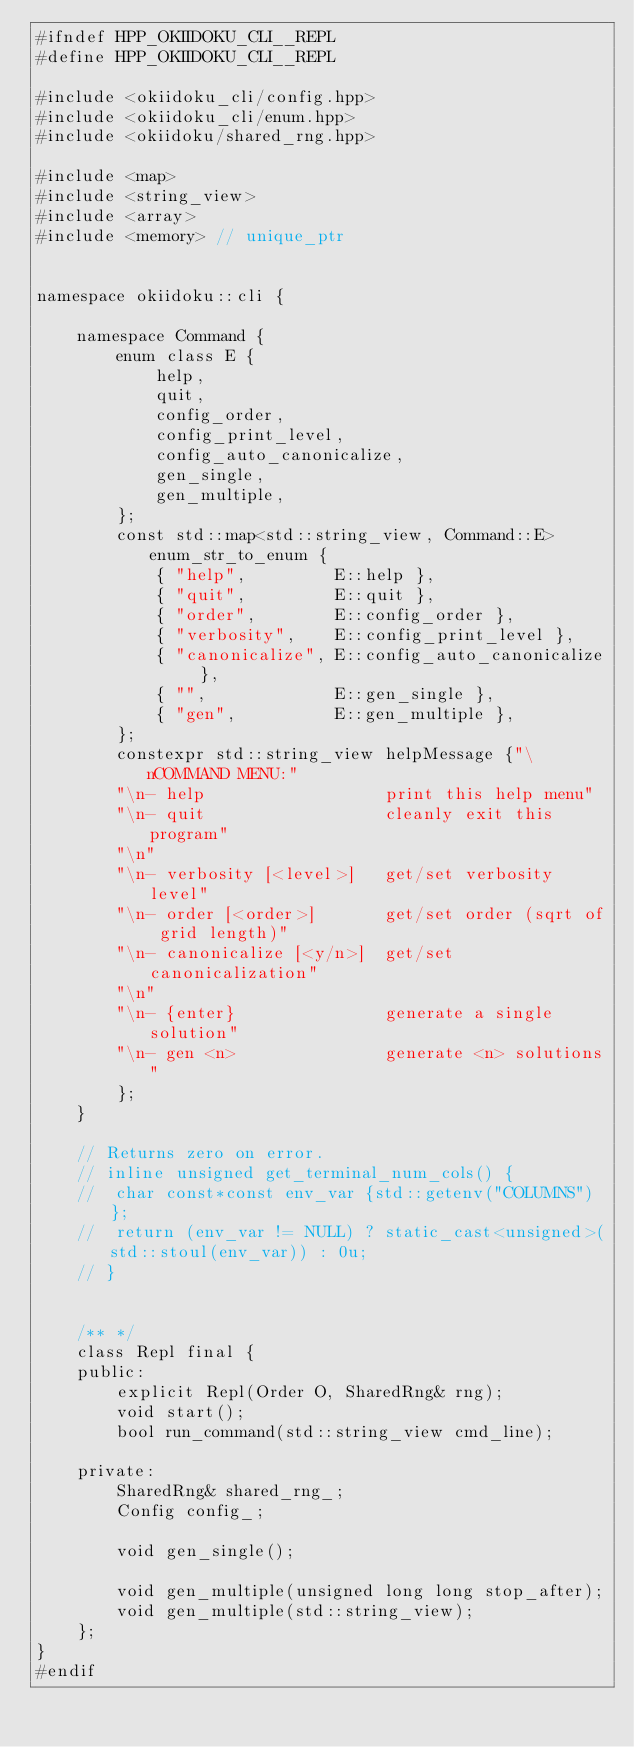Convert code to text. <code><loc_0><loc_0><loc_500><loc_500><_C++_>#ifndef HPP_OKIIDOKU_CLI__REPL
#define HPP_OKIIDOKU_CLI__REPL

#include <okiidoku_cli/config.hpp>
#include <okiidoku_cli/enum.hpp>
#include <okiidoku/shared_rng.hpp>

#include <map>
#include <string_view>
#include <array>
#include <memory> // unique_ptr


namespace okiidoku::cli {

	namespace Command {
		enum class E {
			help,
			quit,
			config_order,
			config_print_level,
			config_auto_canonicalize,
			gen_single,
			gen_multiple,
		};
		const std::map<std::string_view, Command::E> enum_str_to_enum {
			{ "help",         E::help },
			{ "quit",         E::quit },
			{ "order",        E::config_order },
			{ "verbosity",    E::config_print_level },
			{ "canonicalize", E::config_auto_canonicalize },
			{ "",             E::gen_single },
			{ "gen",          E::gen_multiple },
		};
		constexpr std::string_view helpMessage {"\nCOMMAND MENU:"
		"\n- help                  print this help menu"
		"\n- quit                  cleanly exit this program"
		"\n"
		"\n- verbosity [<level>]   get/set verbosity level"
		"\n- order [<order>]       get/set order (sqrt of grid length)"
		"\n- canonicalize [<y/n>]  get/set canonicalization"
		"\n"
		"\n- {enter}               generate a single solution"
		"\n- gen <n>               generate <n> solutions"
		};
	}

	// Returns zero on error.
	// inline unsigned get_terminal_num_cols() {
	// 	char const*const env_var {std::getenv("COLUMNS")};
	// 	return (env_var != NULL) ? static_cast<unsigned>(std::stoul(env_var)) : 0u;
	// }


	/** */
	class Repl final {
	public:
		explicit Repl(Order O, SharedRng& rng);
		void start();
		bool run_command(std::string_view cmd_line);

	private:
		SharedRng& shared_rng_;
		Config config_;

		void gen_single();

		void gen_multiple(unsigned long long stop_after);
		void gen_multiple(std::string_view);
	};
}
#endif</code> 